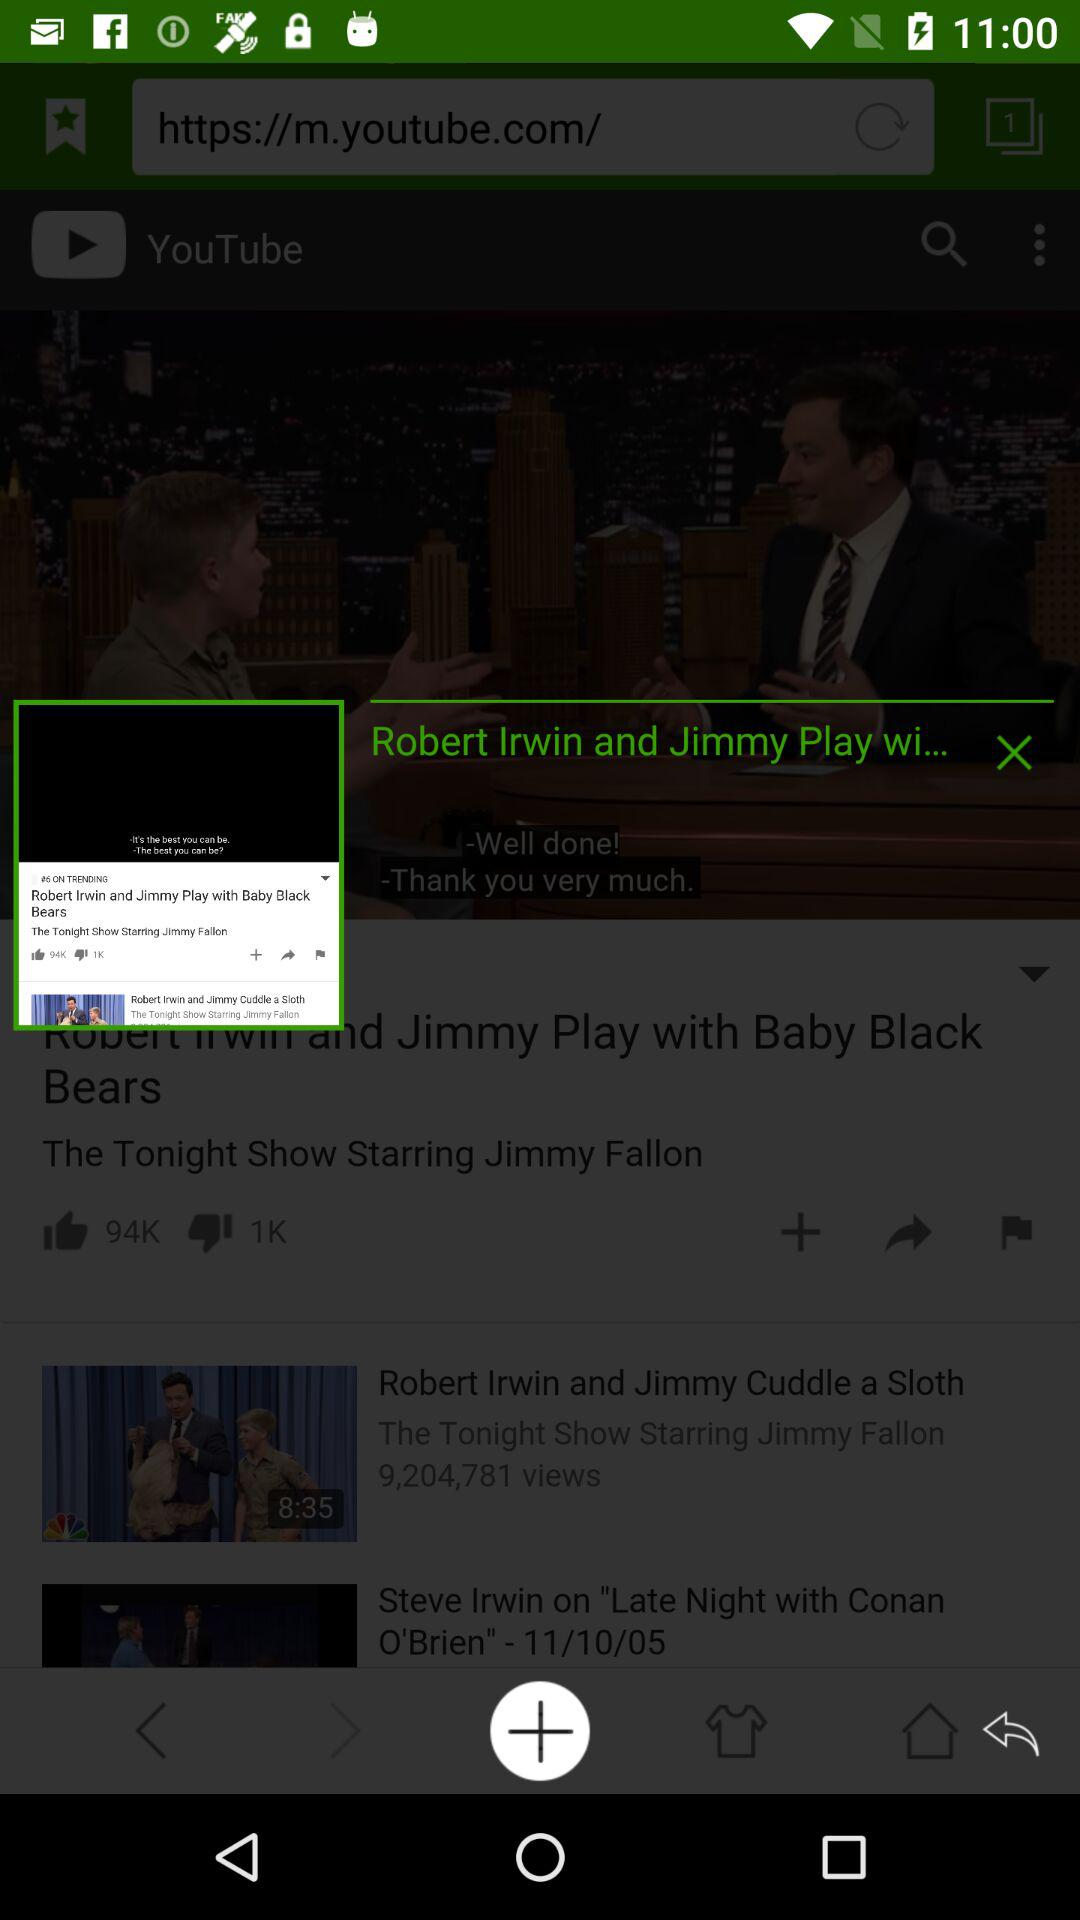What is the uploaded date of the "Late Night with Conan O'Brien" video? The uploaded date is November 10, 2005. 